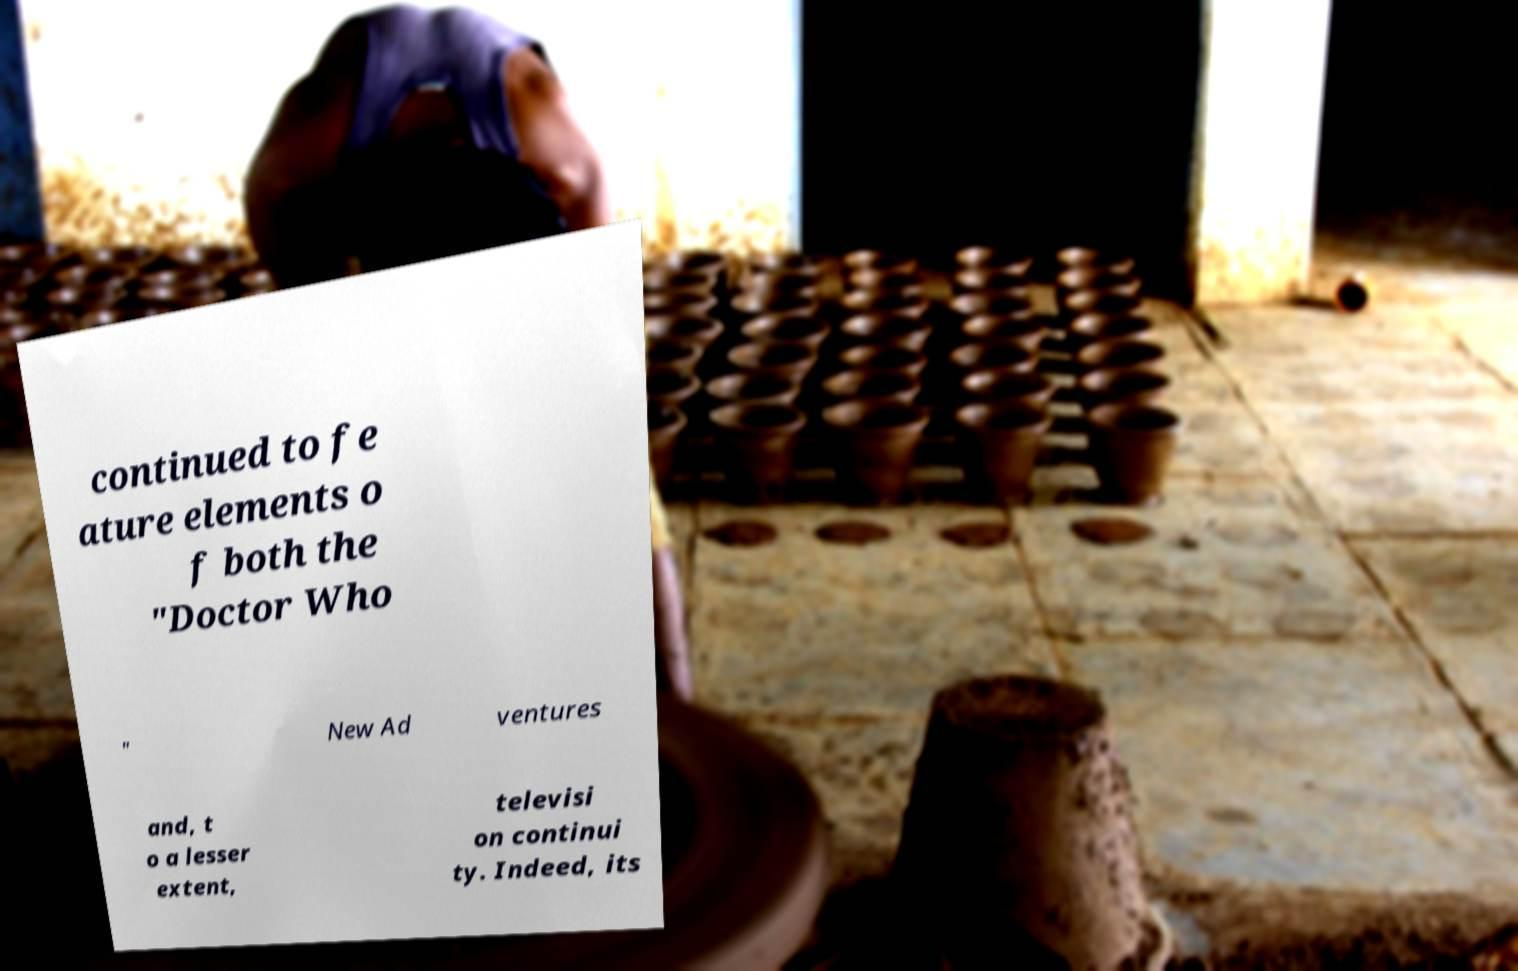Could you assist in decoding the text presented in this image and type it out clearly? continued to fe ature elements o f both the "Doctor Who " New Ad ventures and, t o a lesser extent, televisi on continui ty. Indeed, its 